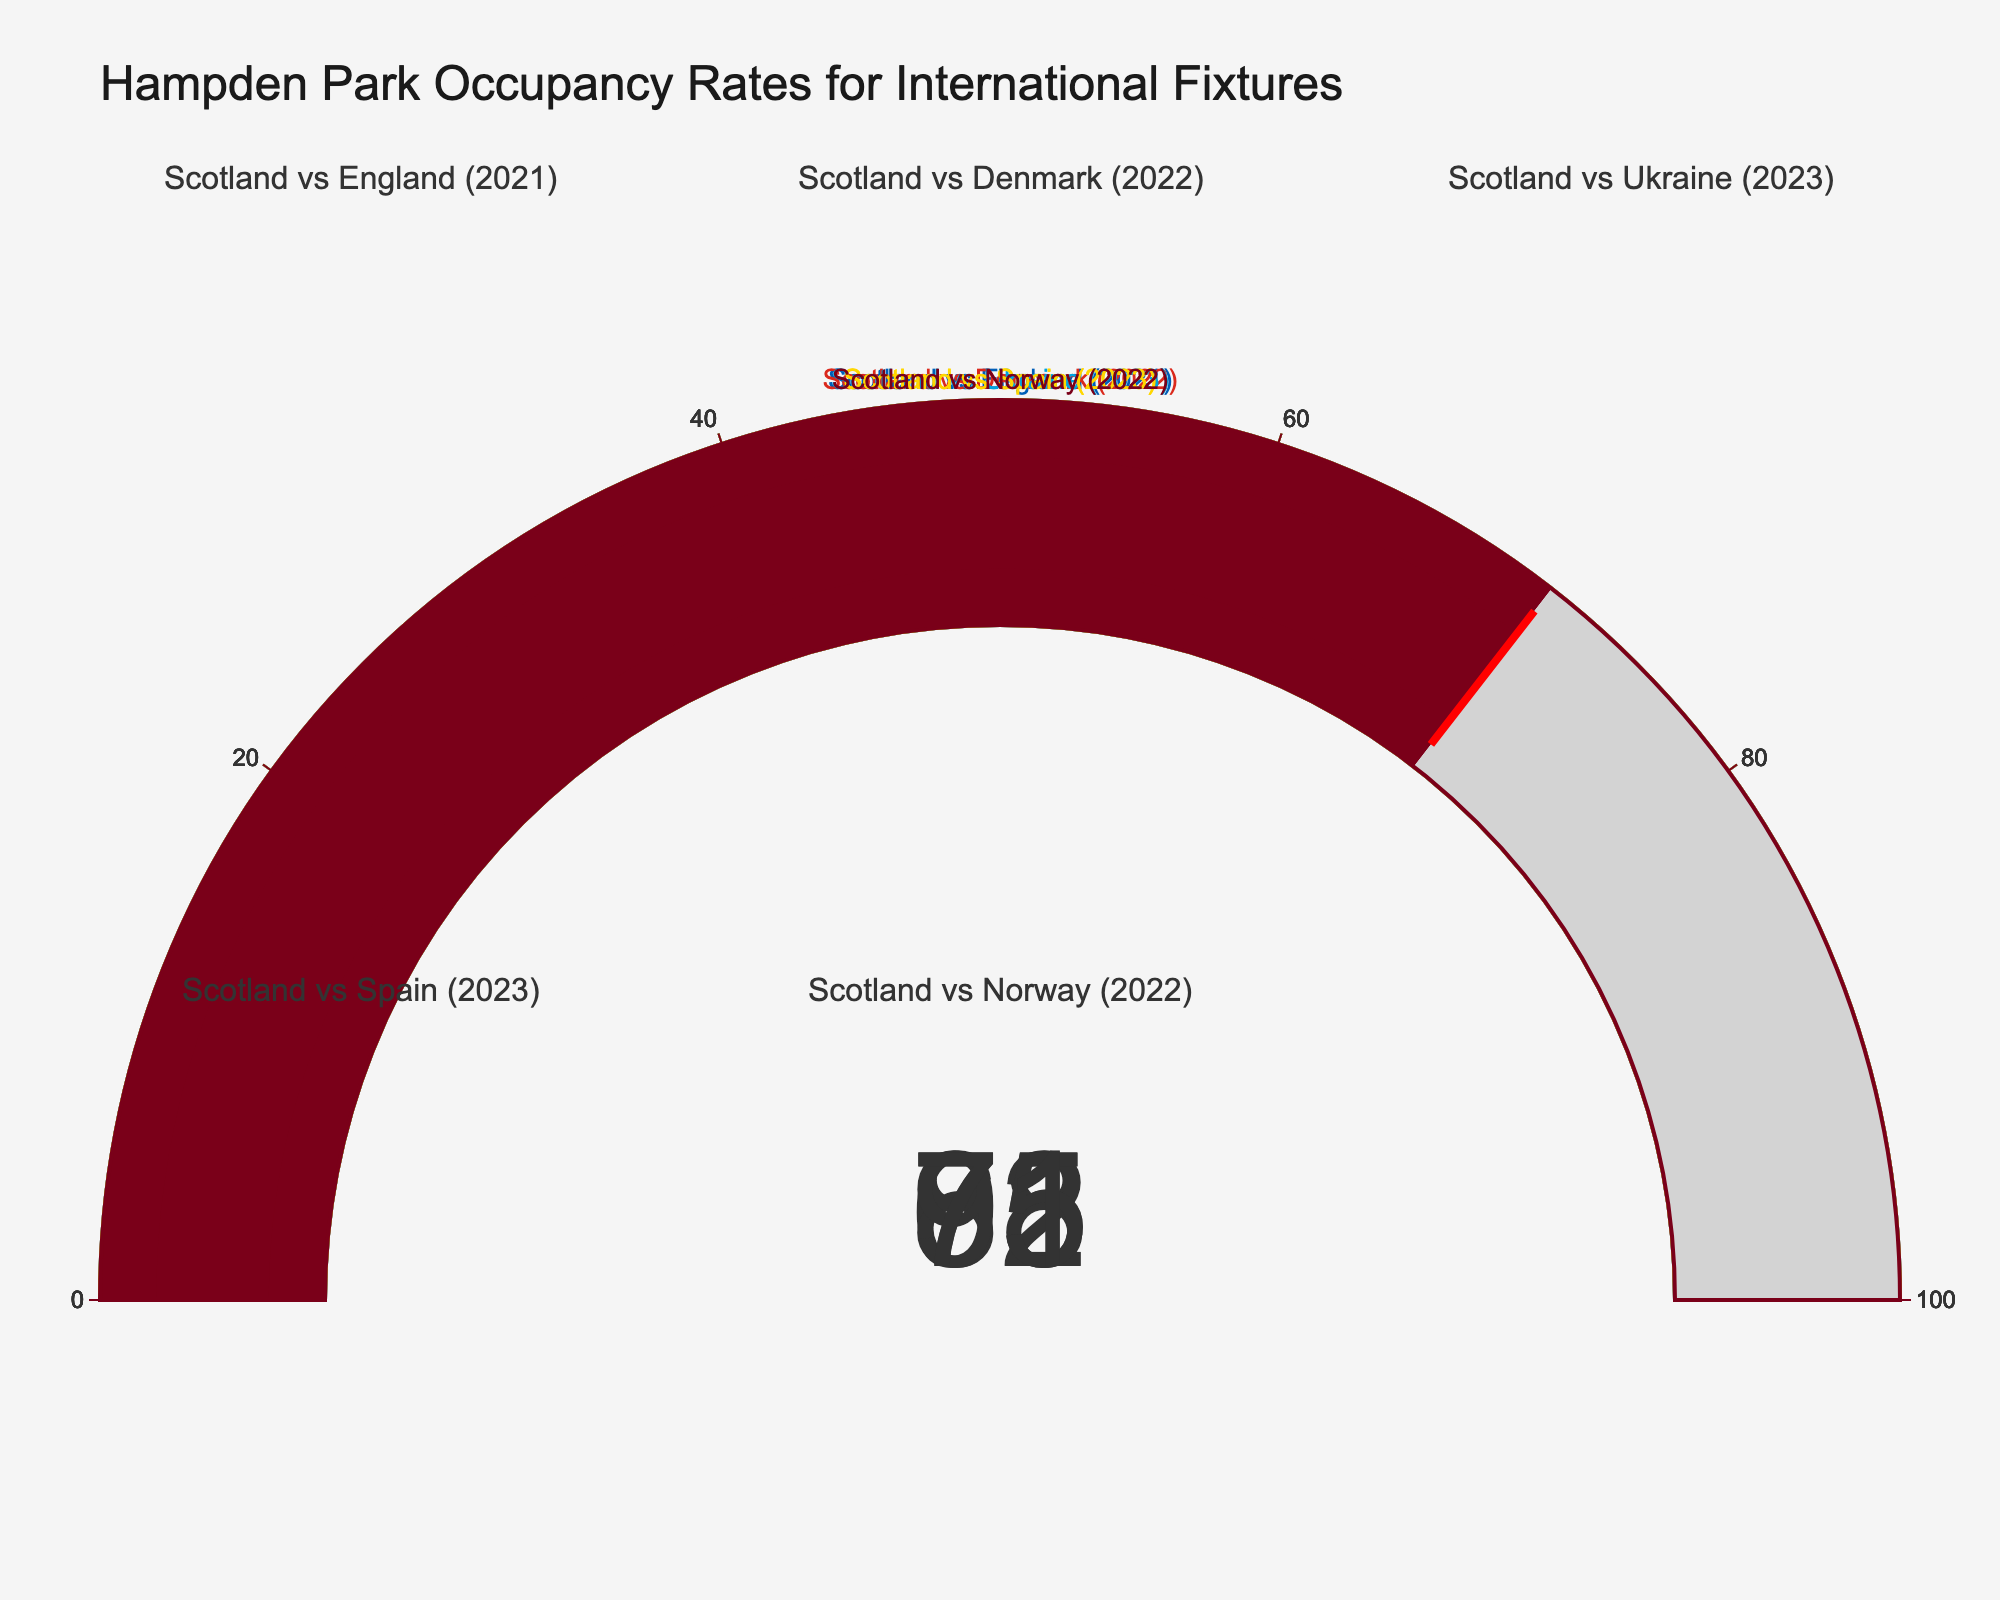What is the occupancy rate for the match between Scotland and Spain (2023)? The gauge for the "Scotland vs Spain (2023)" match shows a value of 95.
Answer: 95 Which match has the lowest occupancy rate? By examining all the gauges, the "Scotland vs Denmark (2022)" match has the lowest rate at 65.
Answer: Scotland vs Denmark (2022) What is the average occupancy rate across all the listed matches? The occupancy rates are 78, 65, 82, 95, 71. Summing these gives 391, and dividing by 5 (number of matches) results in 78.2.
Answer: 78.2 How much higher is the occupancy rate of Scotland vs Spain (2023) compared to Scotland vs Ukraine (2023)? The occupancy rate for Scotland vs Spain (2023) is 95, and for Scotland vs Ukraine (2023) it is 82. The difference is 95 - 82 = 13.
Answer: 13 Which matches have occupancy rates greater than 80? From the figures, Scotland vs Ukraine (2023) with 82 and Scotland vs Spain (2023) with 95 have rates greater than 80.
Answer: Scotland vs Ukraine (2023), Scotland vs Spain (2023) How many matches had an occupancy rate below 75? By checking the values, Scotland vs Denmark (2022) with 65 and Scotland vs Norway (2022) with 71 have rates below 75.
Answer: 2 For the displayed matches, which year had the highest average occupancy rate? The matches are grouped by year: 2021 (78), 2022 (65, 71), 2023 (82, 95). Averages are 2021: 78, 2022: (65+71)/2=68, 2023: (82+95)/2=88.5; 2023 has the highest average.
Answer: 2023 What is the difference in occupancy rates between the Scotland vs England (2021) and Scotland vs Norway (2022) matches? The rate for Scotland vs England (2021) is 78, and for Scotland vs Norway (2022) it is 71. The difference is 78 - 71 = 7.
Answer: 7 What is the total occupancy rate of all matches combined? Summing the occupancy rates of all matches: 78 + 65 + 82 + 95 + 71 = 391.
Answer: 391 Which match has the second-highest occupancy rate? By examining the values, the highest is 95 (Scotland vs Spain), and the second-highest is 82 (Scotland vs Ukraine).
Answer: Scotland vs Ukraine (2023) 